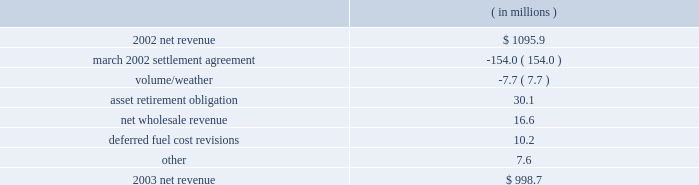Entergy arkansas , inc .
Management's financial discussion and analysis fuel and purchased power expenses increased primarily due to increased recovery of deferred fuel and purchased power costs primarily due to an increase in april 2004 in the energy cost recovery rider and the true-ups to the 2003 and 2002 energy cost recovery rider filings .
Other regulatory credits decreased primarily due to the over-recovery of grand gulf costs due to an increase in the grand gulf rider effective january 2004 .
2003 compared to 2002 net revenue , which is entergy arkansas' measure of gross margin , consists of operating revenues net of : 1 ) fuel , fuel-related , and purchased power expenses and 2 ) other regulatory credits .
Following is an analysis of the change in net revenue comparing 2003 to 2002. .
The march 2002 settlement agreement resolved a request for recovery of ice storm costs incurred in december 2000 with an offset of those costs for funds contributed to pay for future stranded costs .
A 1997 settlement provided for the collection of earnings in excess of an 11% ( 11 % ) return on equity in a transition cost account ( tca ) to offset stranded costs if retail open access were implemented .
In mid- and late december 2000 , two separate ice storms left 226000 and 212500 entergy arkansas customers , respectively , without electric power in its service area .
Entergy arkansas filed a proposal to recover costs plus carrying charges associated with power restoration caused by the ice storms .
Entergy arkansas' final storm damage cost determination reflected costs of approximately $ 195 million .
The apsc approved a settlement agreement submitted in march 2002 by entergy arkansas , the apsc staff , and the arkansas attorney general .
In the march 2002 settlement , the parties agreed that $ 153 million of the ice storm costs would be classified as incremental ice storm expenses that can be offset against the tca on a rate class basis , and any excess of ice storm costs over the amount available in the tca would be deferred and amortized over 30 years , although such excess costs were not allowed to be included as a separate component of rate base .
The allocated ice storm expenses exceeded the available tca funds by $ 15.8 million which was recorded as a regulatory asset in june 2002 .
In accordance with the settlement agreement and following the apsc's approval of the 2001 earnings review related to the tca , entergy arkansas filed to return $ 18.1 million of the tca to certain large general service class customers that paid more into the tca than their allocation of storm costs .
The apsc approved the return of funds to the large general service customer class in the form of refund checks in august 2002 .
As part of the implementation of the march 2002 settlement agreement provisions , the tca procedure ceased with the 2001 earnings evaluation .
Of the remaining ice storm costs , $ 32.2 million was addressed through established ratemaking procedures , including $ 22.2 million classified as capital additions , while $ 3.8 million of the ice storm costs was not recovered through rates .
The effect on net income of the march 2002 settlement agreement and 2001 earnings review was a $ 2.2 million increase in 2003 , because the decrease in net revenue was offset by the decrease in operation and maintenance expenses discussed below. .
What is the growth rate in net revenue in 2003 for entergy arkansas , inc.? 
Computations: ((998.7 - 1095.9) / 1095.9)
Answer: -0.08869. Entergy arkansas , inc .
Management's financial discussion and analysis fuel and purchased power expenses increased primarily due to increased recovery of deferred fuel and purchased power costs primarily due to an increase in april 2004 in the energy cost recovery rider and the true-ups to the 2003 and 2002 energy cost recovery rider filings .
Other regulatory credits decreased primarily due to the over-recovery of grand gulf costs due to an increase in the grand gulf rider effective january 2004 .
2003 compared to 2002 net revenue , which is entergy arkansas' measure of gross margin , consists of operating revenues net of : 1 ) fuel , fuel-related , and purchased power expenses and 2 ) other regulatory credits .
Following is an analysis of the change in net revenue comparing 2003 to 2002. .
The march 2002 settlement agreement resolved a request for recovery of ice storm costs incurred in december 2000 with an offset of those costs for funds contributed to pay for future stranded costs .
A 1997 settlement provided for the collection of earnings in excess of an 11% ( 11 % ) return on equity in a transition cost account ( tca ) to offset stranded costs if retail open access were implemented .
In mid- and late december 2000 , two separate ice storms left 226000 and 212500 entergy arkansas customers , respectively , without electric power in its service area .
Entergy arkansas filed a proposal to recover costs plus carrying charges associated with power restoration caused by the ice storms .
Entergy arkansas' final storm damage cost determination reflected costs of approximately $ 195 million .
The apsc approved a settlement agreement submitted in march 2002 by entergy arkansas , the apsc staff , and the arkansas attorney general .
In the march 2002 settlement , the parties agreed that $ 153 million of the ice storm costs would be classified as incremental ice storm expenses that can be offset against the tca on a rate class basis , and any excess of ice storm costs over the amount available in the tca would be deferred and amortized over 30 years , although such excess costs were not allowed to be included as a separate component of rate base .
The allocated ice storm expenses exceeded the available tca funds by $ 15.8 million which was recorded as a regulatory asset in june 2002 .
In accordance with the settlement agreement and following the apsc's approval of the 2001 earnings review related to the tca , entergy arkansas filed to return $ 18.1 million of the tca to certain large general service class customers that paid more into the tca than their allocation of storm costs .
The apsc approved the return of funds to the large general service customer class in the form of refund checks in august 2002 .
As part of the implementation of the march 2002 settlement agreement provisions , the tca procedure ceased with the 2001 earnings evaluation .
Of the remaining ice storm costs , $ 32.2 million was addressed through established ratemaking procedures , including $ 22.2 million classified as capital additions , while $ 3.8 million of the ice storm costs was not recovered through rates .
The effect on net income of the march 2002 settlement agreement and 2001 earnings review was a $ 2.2 million increase in 2003 , because the decrease in net revenue was offset by the decrease in operation and maintenance expenses discussed below. .
What is the percent change in net revenue from 2002 to 2003? 
Computations: ((1095.9 - 998.7) / 998.7)
Answer: 0.09733. 